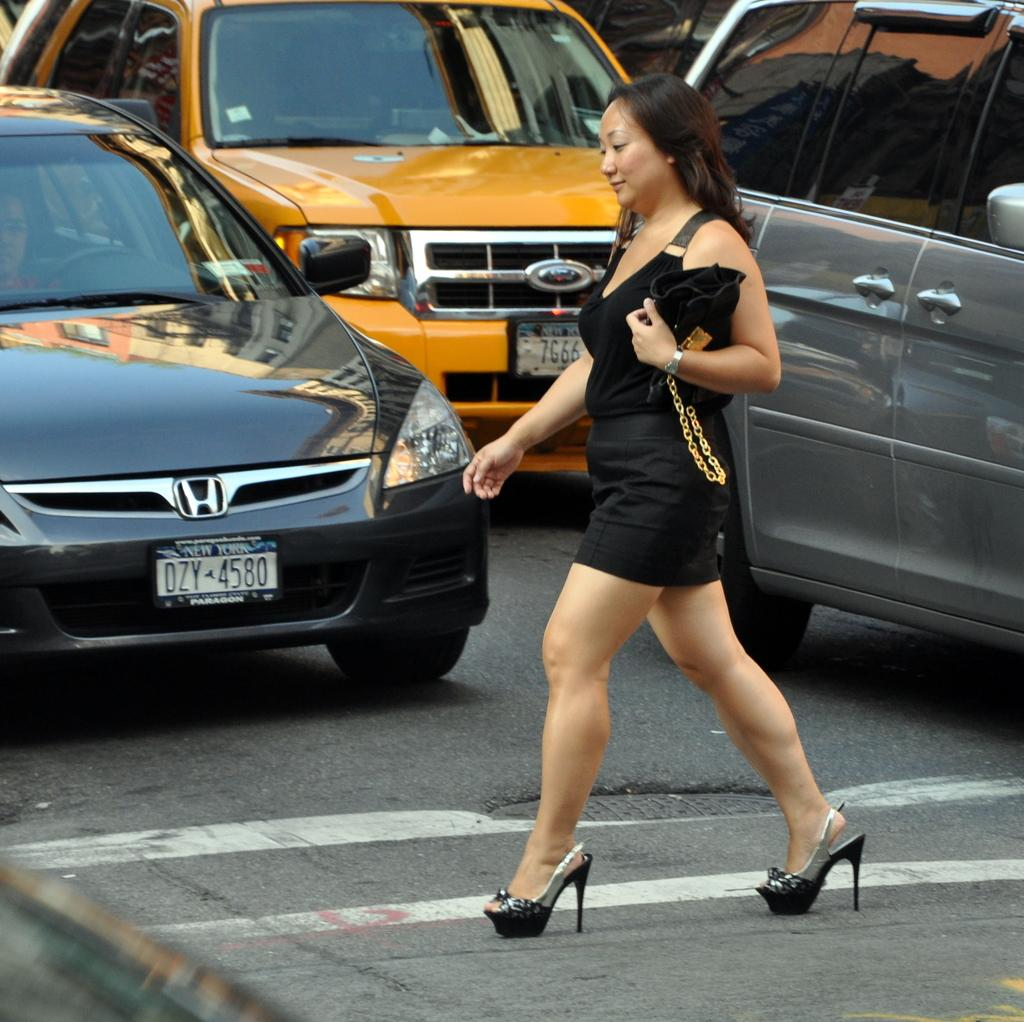<image>
Summarize the visual content of the image. A car with plate DZY4580 stops as a woman walks in front of it. 